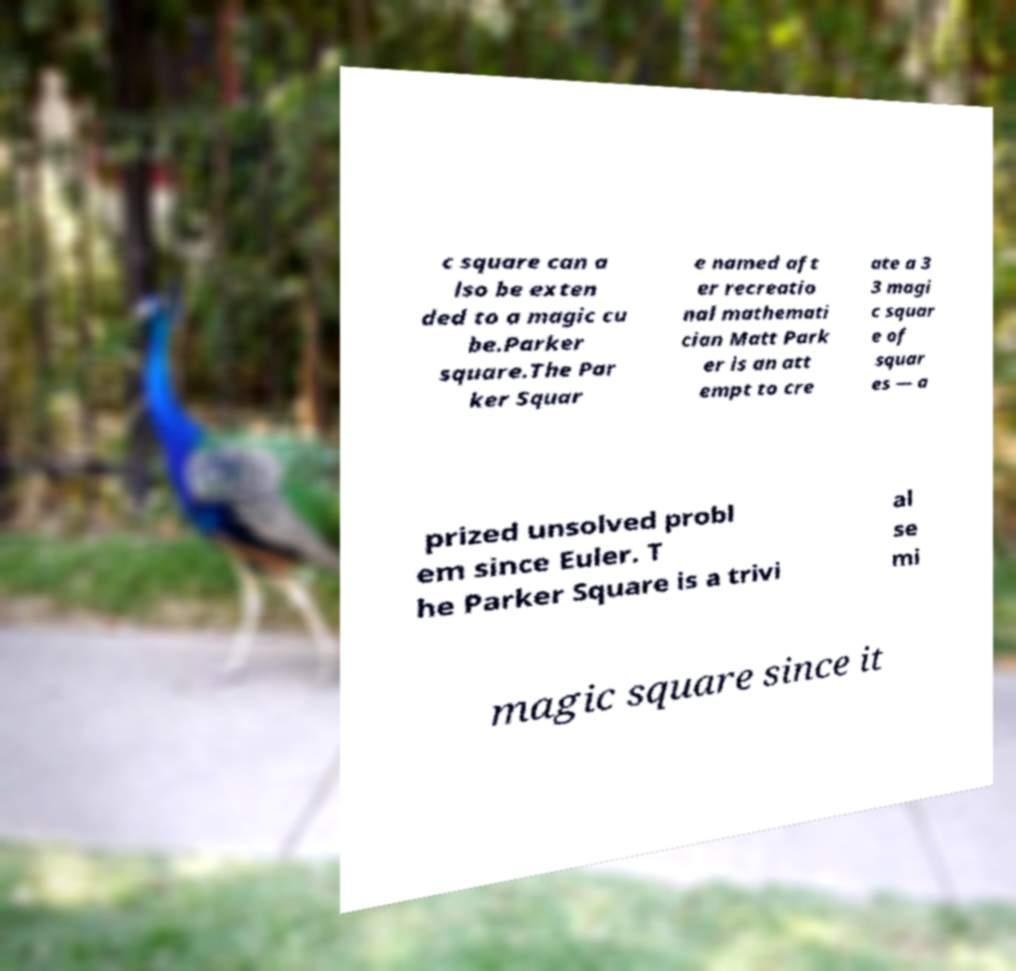Please read and relay the text visible in this image. What does it say? c square can a lso be exten ded to a magic cu be.Parker square.The Par ker Squar e named aft er recreatio nal mathemati cian Matt Park er is an att empt to cre ate a 3 3 magi c squar e of squar es — a prized unsolved probl em since Euler. T he Parker Square is a trivi al se mi magic square since it 